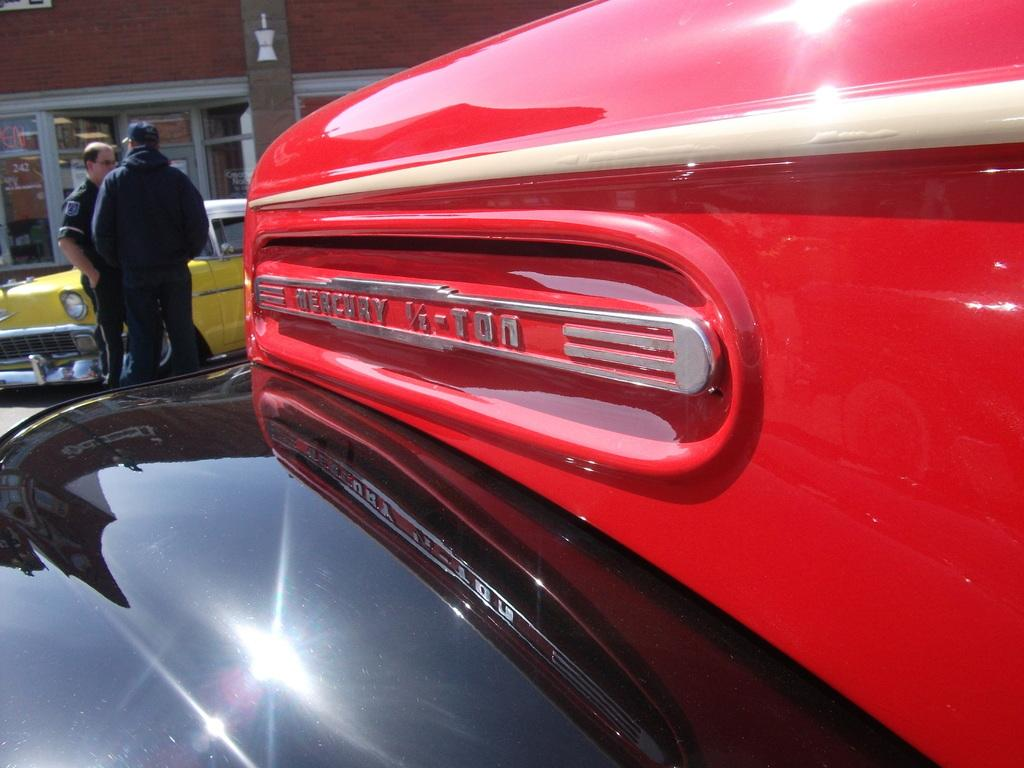<image>
Relay a brief, clear account of the picture shown. Two men are standing by a red and black old truck that says Mercury 1/2-Ton. 